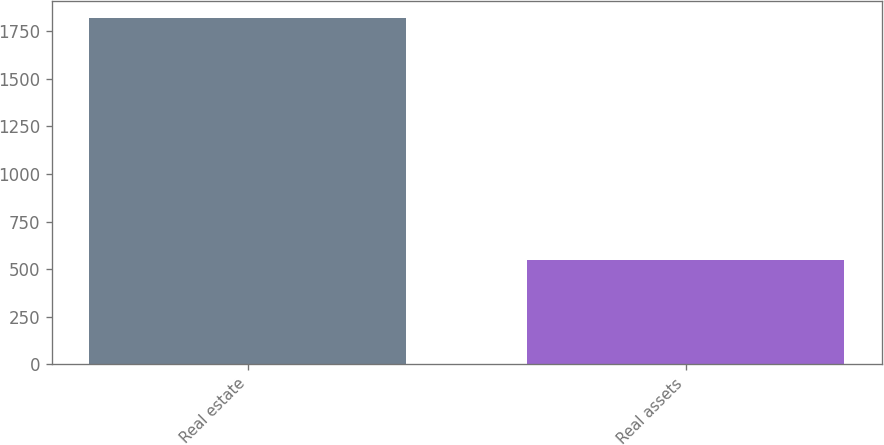Convert chart to OTSL. <chart><loc_0><loc_0><loc_500><loc_500><bar_chart><fcel>Real estate<fcel>Real assets<nl><fcel>1819<fcel>548<nl></chart> 